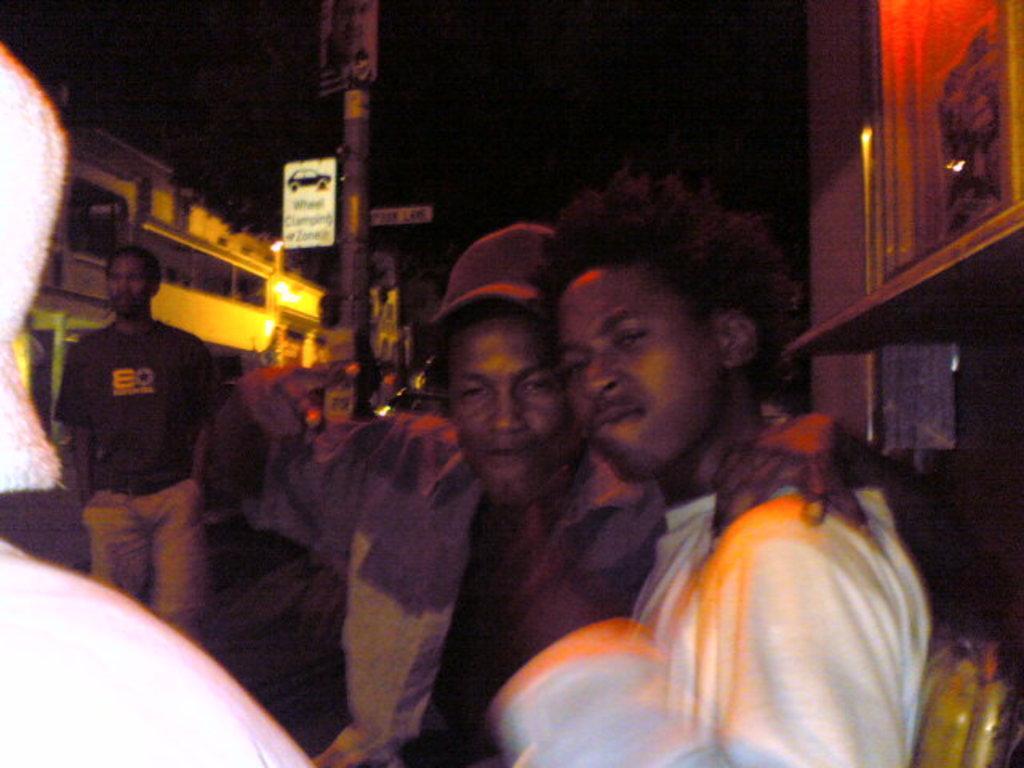In one or two sentences, can you explain what this image depicts? In the picture we can see two men are standing together and behind them, we can see a pole and near it also we can see a man standing and besides we can see some houses. 